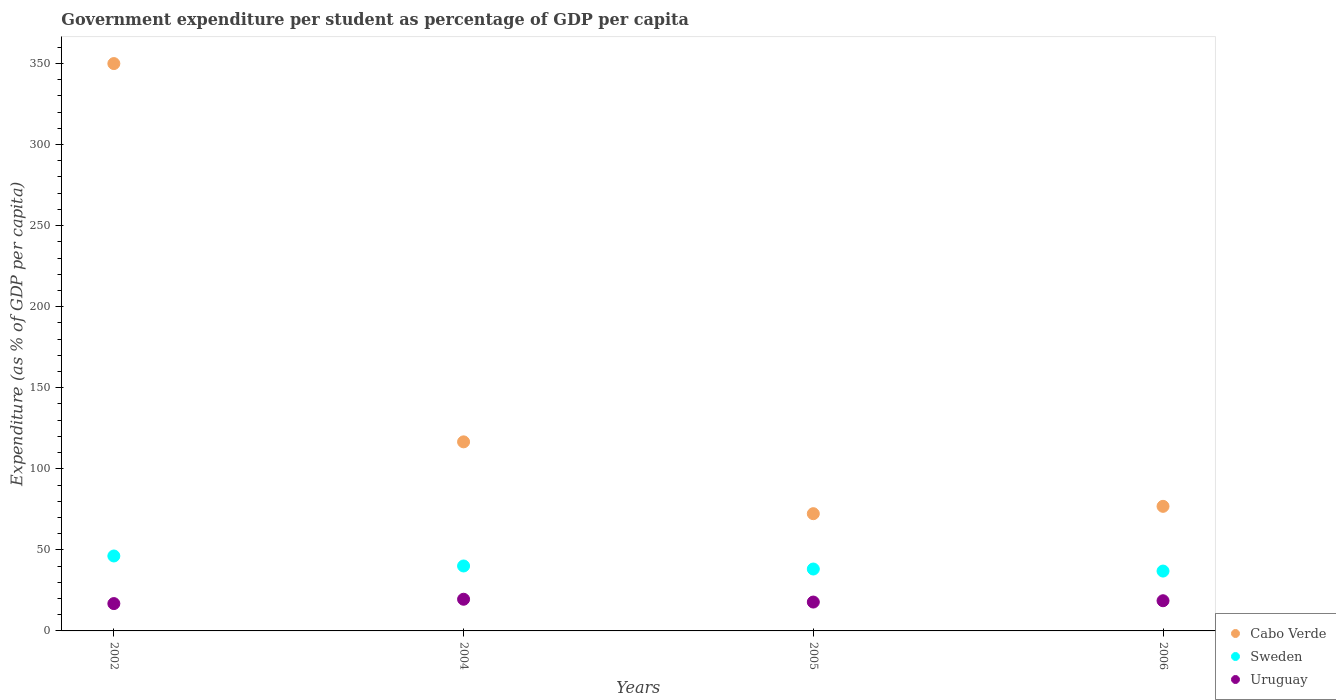How many different coloured dotlines are there?
Offer a terse response. 3. Is the number of dotlines equal to the number of legend labels?
Provide a short and direct response. Yes. What is the percentage of expenditure per student in Cabo Verde in 2004?
Provide a succinct answer. 116.61. Across all years, what is the maximum percentage of expenditure per student in Uruguay?
Your answer should be very brief. 19.54. Across all years, what is the minimum percentage of expenditure per student in Cabo Verde?
Offer a terse response. 72.31. In which year was the percentage of expenditure per student in Sweden maximum?
Make the answer very short. 2002. What is the total percentage of expenditure per student in Uruguay in the graph?
Your answer should be very brief. 72.82. What is the difference between the percentage of expenditure per student in Uruguay in 2004 and that in 2005?
Offer a very short reply. 1.73. What is the difference between the percentage of expenditure per student in Uruguay in 2006 and the percentage of expenditure per student in Sweden in 2002?
Provide a short and direct response. -27.61. What is the average percentage of expenditure per student in Sweden per year?
Your answer should be compact. 40.34. In the year 2006, what is the difference between the percentage of expenditure per student in Cabo Verde and percentage of expenditure per student in Uruguay?
Your answer should be very brief. 58.23. In how many years, is the percentage of expenditure per student in Uruguay greater than 220 %?
Your response must be concise. 0. What is the ratio of the percentage of expenditure per student in Sweden in 2002 to that in 2004?
Give a very brief answer. 1.15. Is the difference between the percentage of expenditure per student in Cabo Verde in 2002 and 2004 greater than the difference between the percentage of expenditure per student in Uruguay in 2002 and 2004?
Make the answer very short. Yes. What is the difference between the highest and the second highest percentage of expenditure per student in Cabo Verde?
Give a very brief answer. 233.32. What is the difference between the highest and the lowest percentage of expenditure per student in Sweden?
Offer a very short reply. 9.3. Is the sum of the percentage of expenditure per student in Cabo Verde in 2004 and 2005 greater than the maximum percentage of expenditure per student in Uruguay across all years?
Keep it short and to the point. Yes. Is the percentage of expenditure per student in Sweden strictly greater than the percentage of expenditure per student in Cabo Verde over the years?
Offer a terse response. No. Is the percentage of expenditure per student in Uruguay strictly less than the percentage of expenditure per student in Cabo Verde over the years?
Your answer should be very brief. Yes. How many years are there in the graph?
Your response must be concise. 4. Where does the legend appear in the graph?
Your answer should be compact. Bottom right. How many legend labels are there?
Give a very brief answer. 3. What is the title of the graph?
Ensure brevity in your answer.  Government expenditure per student as percentage of GDP per capita. What is the label or title of the Y-axis?
Offer a very short reply. Expenditure (as % of GDP per capita). What is the Expenditure (as % of GDP per capita) of Cabo Verde in 2002?
Ensure brevity in your answer.  349.93. What is the Expenditure (as % of GDP per capita) of Sweden in 2002?
Offer a terse response. 46.22. What is the Expenditure (as % of GDP per capita) of Uruguay in 2002?
Provide a short and direct response. 16.86. What is the Expenditure (as % of GDP per capita) in Cabo Verde in 2004?
Your answer should be compact. 116.61. What is the Expenditure (as % of GDP per capita) in Sweden in 2004?
Provide a short and direct response. 40.05. What is the Expenditure (as % of GDP per capita) in Uruguay in 2004?
Give a very brief answer. 19.54. What is the Expenditure (as % of GDP per capita) in Cabo Verde in 2005?
Your answer should be very brief. 72.31. What is the Expenditure (as % of GDP per capita) of Sweden in 2005?
Your response must be concise. 38.18. What is the Expenditure (as % of GDP per capita) of Uruguay in 2005?
Your answer should be very brief. 17.81. What is the Expenditure (as % of GDP per capita) of Cabo Verde in 2006?
Offer a terse response. 76.84. What is the Expenditure (as % of GDP per capita) in Sweden in 2006?
Provide a succinct answer. 36.92. What is the Expenditure (as % of GDP per capita) in Uruguay in 2006?
Offer a terse response. 18.62. Across all years, what is the maximum Expenditure (as % of GDP per capita) in Cabo Verde?
Offer a terse response. 349.93. Across all years, what is the maximum Expenditure (as % of GDP per capita) of Sweden?
Make the answer very short. 46.22. Across all years, what is the maximum Expenditure (as % of GDP per capita) of Uruguay?
Offer a very short reply. 19.54. Across all years, what is the minimum Expenditure (as % of GDP per capita) in Cabo Verde?
Make the answer very short. 72.31. Across all years, what is the minimum Expenditure (as % of GDP per capita) of Sweden?
Offer a terse response. 36.92. Across all years, what is the minimum Expenditure (as % of GDP per capita) of Uruguay?
Keep it short and to the point. 16.86. What is the total Expenditure (as % of GDP per capita) of Cabo Verde in the graph?
Ensure brevity in your answer.  615.69. What is the total Expenditure (as % of GDP per capita) in Sweden in the graph?
Offer a terse response. 161.37. What is the total Expenditure (as % of GDP per capita) in Uruguay in the graph?
Give a very brief answer. 72.82. What is the difference between the Expenditure (as % of GDP per capita) in Cabo Verde in 2002 and that in 2004?
Your answer should be compact. 233.32. What is the difference between the Expenditure (as % of GDP per capita) in Sweden in 2002 and that in 2004?
Keep it short and to the point. 6.17. What is the difference between the Expenditure (as % of GDP per capita) of Uruguay in 2002 and that in 2004?
Your answer should be very brief. -2.68. What is the difference between the Expenditure (as % of GDP per capita) in Cabo Verde in 2002 and that in 2005?
Offer a terse response. 277.62. What is the difference between the Expenditure (as % of GDP per capita) of Sweden in 2002 and that in 2005?
Your response must be concise. 8.04. What is the difference between the Expenditure (as % of GDP per capita) of Uruguay in 2002 and that in 2005?
Provide a short and direct response. -0.95. What is the difference between the Expenditure (as % of GDP per capita) in Cabo Verde in 2002 and that in 2006?
Your response must be concise. 273.09. What is the difference between the Expenditure (as % of GDP per capita) of Sweden in 2002 and that in 2006?
Give a very brief answer. 9.3. What is the difference between the Expenditure (as % of GDP per capita) in Uruguay in 2002 and that in 2006?
Offer a very short reply. -1.76. What is the difference between the Expenditure (as % of GDP per capita) in Cabo Verde in 2004 and that in 2005?
Your answer should be compact. 44.3. What is the difference between the Expenditure (as % of GDP per capita) in Sweden in 2004 and that in 2005?
Make the answer very short. 1.87. What is the difference between the Expenditure (as % of GDP per capita) in Uruguay in 2004 and that in 2005?
Your answer should be very brief. 1.73. What is the difference between the Expenditure (as % of GDP per capita) in Cabo Verde in 2004 and that in 2006?
Provide a short and direct response. 39.77. What is the difference between the Expenditure (as % of GDP per capita) of Sweden in 2004 and that in 2006?
Your answer should be very brief. 3.14. What is the difference between the Expenditure (as % of GDP per capita) of Uruguay in 2004 and that in 2006?
Offer a very short reply. 0.92. What is the difference between the Expenditure (as % of GDP per capita) of Cabo Verde in 2005 and that in 2006?
Provide a short and direct response. -4.53. What is the difference between the Expenditure (as % of GDP per capita) in Sweden in 2005 and that in 2006?
Provide a succinct answer. 1.26. What is the difference between the Expenditure (as % of GDP per capita) in Uruguay in 2005 and that in 2006?
Offer a very short reply. -0.81. What is the difference between the Expenditure (as % of GDP per capita) in Cabo Verde in 2002 and the Expenditure (as % of GDP per capita) in Sweden in 2004?
Your answer should be compact. 309.87. What is the difference between the Expenditure (as % of GDP per capita) of Cabo Verde in 2002 and the Expenditure (as % of GDP per capita) of Uruguay in 2004?
Make the answer very short. 330.39. What is the difference between the Expenditure (as % of GDP per capita) in Sweden in 2002 and the Expenditure (as % of GDP per capita) in Uruguay in 2004?
Give a very brief answer. 26.69. What is the difference between the Expenditure (as % of GDP per capita) in Cabo Verde in 2002 and the Expenditure (as % of GDP per capita) in Sweden in 2005?
Your response must be concise. 311.75. What is the difference between the Expenditure (as % of GDP per capita) of Cabo Verde in 2002 and the Expenditure (as % of GDP per capita) of Uruguay in 2005?
Offer a very short reply. 332.12. What is the difference between the Expenditure (as % of GDP per capita) in Sweden in 2002 and the Expenditure (as % of GDP per capita) in Uruguay in 2005?
Your answer should be very brief. 28.42. What is the difference between the Expenditure (as % of GDP per capita) in Cabo Verde in 2002 and the Expenditure (as % of GDP per capita) in Sweden in 2006?
Keep it short and to the point. 313.01. What is the difference between the Expenditure (as % of GDP per capita) in Cabo Verde in 2002 and the Expenditure (as % of GDP per capita) in Uruguay in 2006?
Make the answer very short. 331.31. What is the difference between the Expenditure (as % of GDP per capita) in Sweden in 2002 and the Expenditure (as % of GDP per capita) in Uruguay in 2006?
Your answer should be compact. 27.61. What is the difference between the Expenditure (as % of GDP per capita) in Cabo Verde in 2004 and the Expenditure (as % of GDP per capita) in Sweden in 2005?
Your answer should be compact. 78.43. What is the difference between the Expenditure (as % of GDP per capita) in Cabo Verde in 2004 and the Expenditure (as % of GDP per capita) in Uruguay in 2005?
Offer a very short reply. 98.81. What is the difference between the Expenditure (as % of GDP per capita) in Sweden in 2004 and the Expenditure (as % of GDP per capita) in Uruguay in 2005?
Give a very brief answer. 22.25. What is the difference between the Expenditure (as % of GDP per capita) of Cabo Verde in 2004 and the Expenditure (as % of GDP per capita) of Sweden in 2006?
Provide a succinct answer. 79.69. What is the difference between the Expenditure (as % of GDP per capita) of Cabo Verde in 2004 and the Expenditure (as % of GDP per capita) of Uruguay in 2006?
Provide a short and direct response. 98. What is the difference between the Expenditure (as % of GDP per capita) in Sweden in 2004 and the Expenditure (as % of GDP per capita) in Uruguay in 2006?
Your answer should be very brief. 21.44. What is the difference between the Expenditure (as % of GDP per capita) in Cabo Verde in 2005 and the Expenditure (as % of GDP per capita) in Sweden in 2006?
Your response must be concise. 35.39. What is the difference between the Expenditure (as % of GDP per capita) of Cabo Verde in 2005 and the Expenditure (as % of GDP per capita) of Uruguay in 2006?
Provide a succinct answer. 53.7. What is the difference between the Expenditure (as % of GDP per capita) of Sweden in 2005 and the Expenditure (as % of GDP per capita) of Uruguay in 2006?
Provide a succinct answer. 19.56. What is the average Expenditure (as % of GDP per capita) in Cabo Verde per year?
Offer a very short reply. 153.92. What is the average Expenditure (as % of GDP per capita) of Sweden per year?
Offer a terse response. 40.34. What is the average Expenditure (as % of GDP per capita) in Uruguay per year?
Provide a short and direct response. 18.2. In the year 2002, what is the difference between the Expenditure (as % of GDP per capita) of Cabo Verde and Expenditure (as % of GDP per capita) of Sweden?
Provide a succinct answer. 303.71. In the year 2002, what is the difference between the Expenditure (as % of GDP per capita) in Cabo Verde and Expenditure (as % of GDP per capita) in Uruguay?
Your answer should be very brief. 333.07. In the year 2002, what is the difference between the Expenditure (as % of GDP per capita) of Sweden and Expenditure (as % of GDP per capita) of Uruguay?
Your answer should be very brief. 29.36. In the year 2004, what is the difference between the Expenditure (as % of GDP per capita) of Cabo Verde and Expenditure (as % of GDP per capita) of Sweden?
Offer a very short reply. 76.56. In the year 2004, what is the difference between the Expenditure (as % of GDP per capita) in Cabo Verde and Expenditure (as % of GDP per capita) in Uruguay?
Offer a very short reply. 97.08. In the year 2004, what is the difference between the Expenditure (as % of GDP per capita) in Sweden and Expenditure (as % of GDP per capita) in Uruguay?
Offer a terse response. 20.52. In the year 2005, what is the difference between the Expenditure (as % of GDP per capita) of Cabo Verde and Expenditure (as % of GDP per capita) of Sweden?
Give a very brief answer. 34.13. In the year 2005, what is the difference between the Expenditure (as % of GDP per capita) in Cabo Verde and Expenditure (as % of GDP per capita) in Uruguay?
Offer a very short reply. 54.5. In the year 2005, what is the difference between the Expenditure (as % of GDP per capita) of Sweden and Expenditure (as % of GDP per capita) of Uruguay?
Give a very brief answer. 20.37. In the year 2006, what is the difference between the Expenditure (as % of GDP per capita) in Cabo Verde and Expenditure (as % of GDP per capita) in Sweden?
Your answer should be compact. 39.93. In the year 2006, what is the difference between the Expenditure (as % of GDP per capita) in Cabo Verde and Expenditure (as % of GDP per capita) in Uruguay?
Your response must be concise. 58.23. In the year 2006, what is the difference between the Expenditure (as % of GDP per capita) in Sweden and Expenditure (as % of GDP per capita) in Uruguay?
Keep it short and to the point. 18.3. What is the ratio of the Expenditure (as % of GDP per capita) of Cabo Verde in 2002 to that in 2004?
Your response must be concise. 3. What is the ratio of the Expenditure (as % of GDP per capita) in Sweden in 2002 to that in 2004?
Keep it short and to the point. 1.15. What is the ratio of the Expenditure (as % of GDP per capita) of Uruguay in 2002 to that in 2004?
Your answer should be compact. 0.86. What is the ratio of the Expenditure (as % of GDP per capita) in Cabo Verde in 2002 to that in 2005?
Give a very brief answer. 4.84. What is the ratio of the Expenditure (as % of GDP per capita) in Sweden in 2002 to that in 2005?
Provide a short and direct response. 1.21. What is the ratio of the Expenditure (as % of GDP per capita) in Uruguay in 2002 to that in 2005?
Offer a terse response. 0.95. What is the ratio of the Expenditure (as % of GDP per capita) in Cabo Verde in 2002 to that in 2006?
Provide a succinct answer. 4.55. What is the ratio of the Expenditure (as % of GDP per capita) of Sweden in 2002 to that in 2006?
Your answer should be compact. 1.25. What is the ratio of the Expenditure (as % of GDP per capita) in Uruguay in 2002 to that in 2006?
Provide a succinct answer. 0.91. What is the ratio of the Expenditure (as % of GDP per capita) in Cabo Verde in 2004 to that in 2005?
Offer a very short reply. 1.61. What is the ratio of the Expenditure (as % of GDP per capita) of Sweden in 2004 to that in 2005?
Provide a short and direct response. 1.05. What is the ratio of the Expenditure (as % of GDP per capita) of Uruguay in 2004 to that in 2005?
Your response must be concise. 1.1. What is the ratio of the Expenditure (as % of GDP per capita) in Cabo Verde in 2004 to that in 2006?
Offer a terse response. 1.52. What is the ratio of the Expenditure (as % of GDP per capita) of Sweden in 2004 to that in 2006?
Your response must be concise. 1.08. What is the ratio of the Expenditure (as % of GDP per capita) of Uruguay in 2004 to that in 2006?
Provide a short and direct response. 1.05. What is the ratio of the Expenditure (as % of GDP per capita) in Cabo Verde in 2005 to that in 2006?
Keep it short and to the point. 0.94. What is the ratio of the Expenditure (as % of GDP per capita) in Sweden in 2005 to that in 2006?
Keep it short and to the point. 1.03. What is the ratio of the Expenditure (as % of GDP per capita) in Uruguay in 2005 to that in 2006?
Your answer should be very brief. 0.96. What is the difference between the highest and the second highest Expenditure (as % of GDP per capita) of Cabo Verde?
Make the answer very short. 233.32. What is the difference between the highest and the second highest Expenditure (as % of GDP per capita) of Sweden?
Keep it short and to the point. 6.17. What is the difference between the highest and the second highest Expenditure (as % of GDP per capita) of Uruguay?
Offer a terse response. 0.92. What is the difference between the highest and the lowest Expenditure (as % of GDP per capita) in Cabo Verde?
Make the answer very short. 277.62. What is the difference between the highest and the lowest Expenditure (as % of GDP per capita) in Sweden?
Keep it short and to the point. 9.3. What is the difference between the highest and the lowest Expenditure (as % of GDP per capita) in Uruguay?
Ensure brevity in your answer.  2.68. 